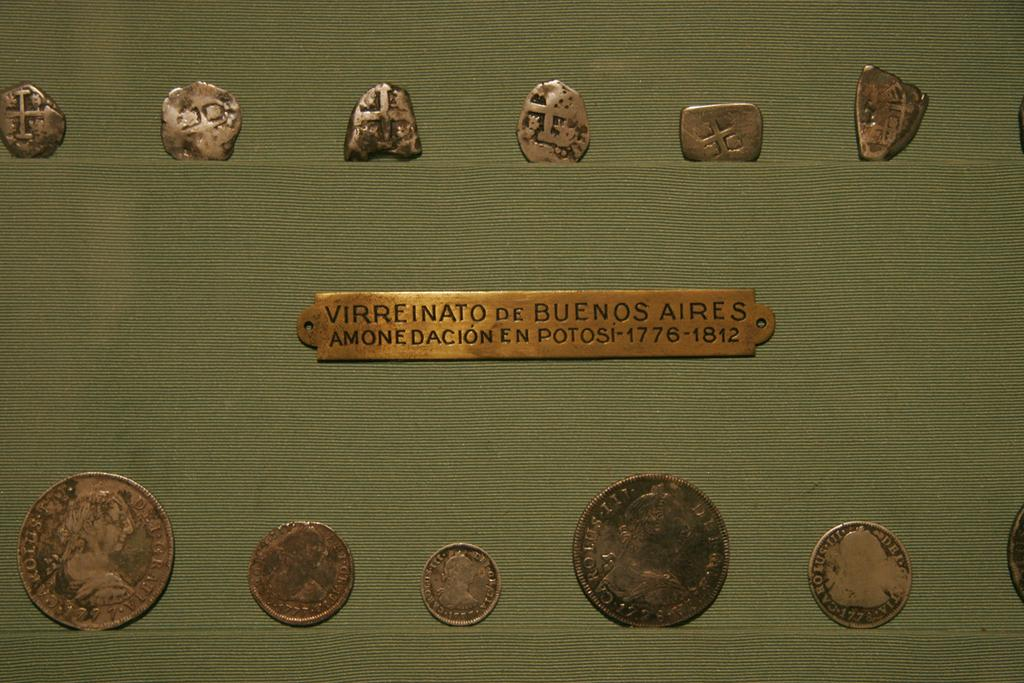<image>
Give a short and clear explanation of the subsequent image. a series of old metal coins with an id tag reading virreinato de buenos aires between them 